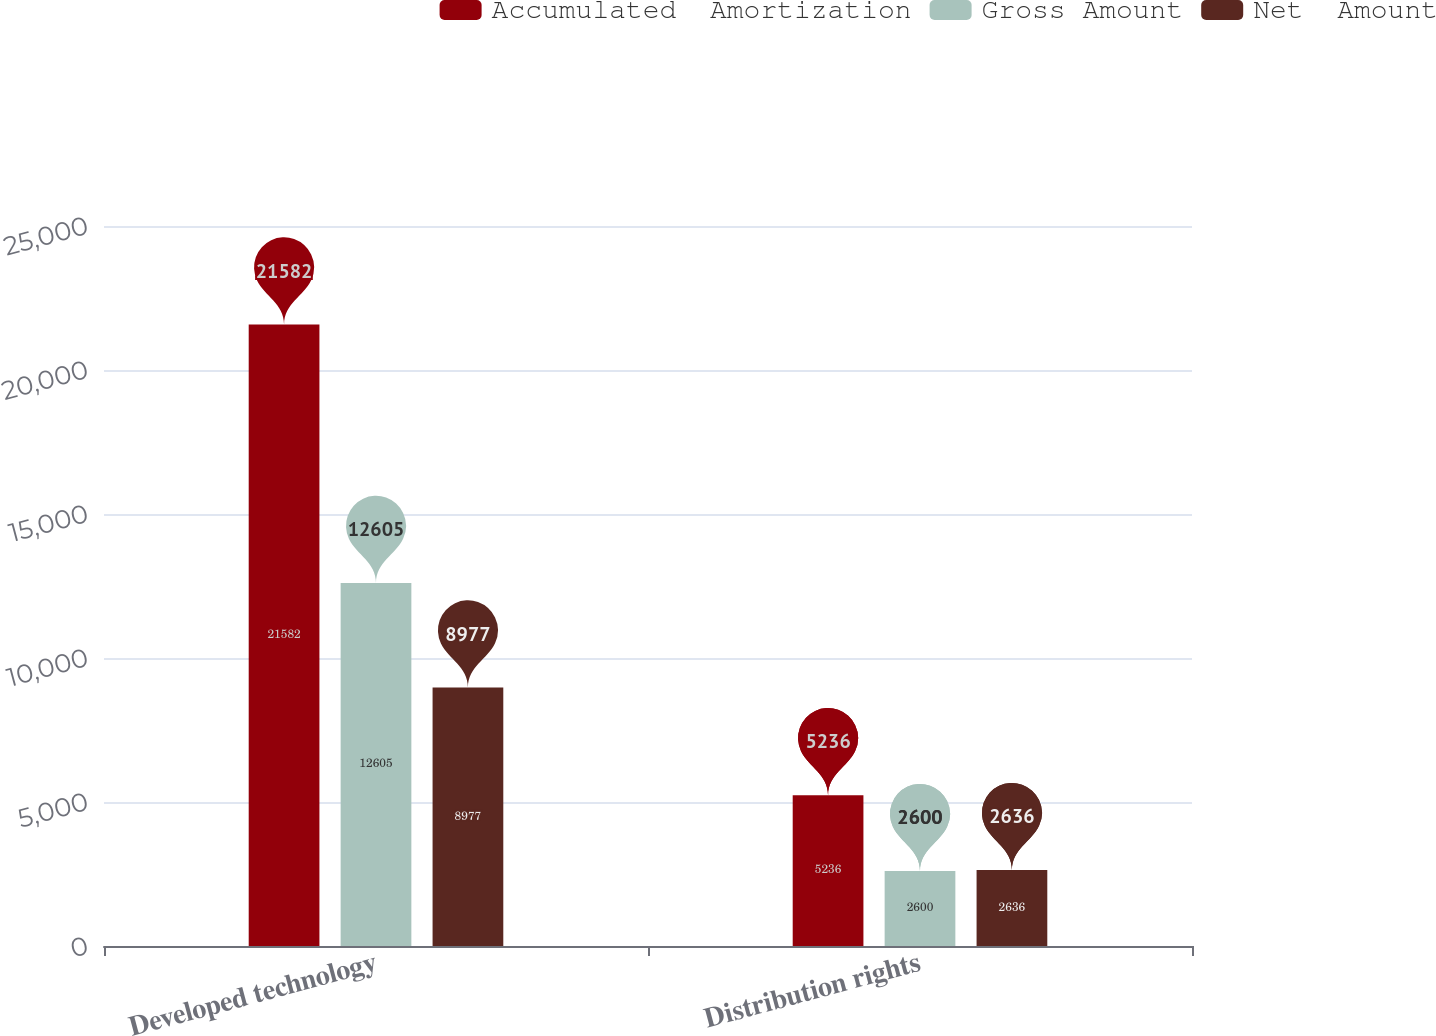Convert chart. <chart><loc_0><loc_0><loc_500><loc_500><stacked_bar_chart><ecel><fcel>Developed technology<fcel>Distribution rights<nl><fcel>Accumulated  Amortization<fcel>21582<fcel>5236<nl><fcel>Gross Amount<fcel>12605<fcel>2600<nl><fcel>Net  Amount<fcel>8977<fcel>2636<nl></chart> 